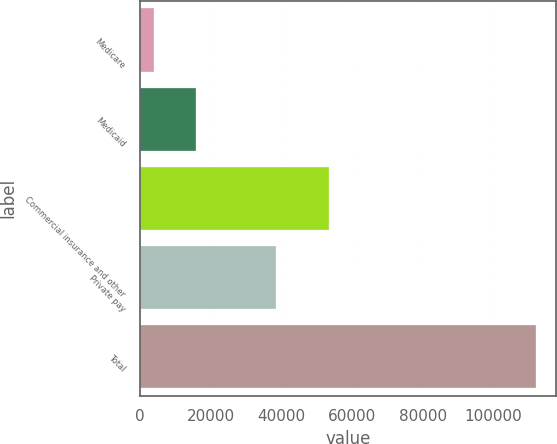Convert chart to OTSL. <chart><loc_0><loc_0><loc_500><loc_500><bar_chart><fcel>Medicare<fcel>Medicaid<fcel>Commercial insurance and other<fcel>Private pay<fcel>Total<nl><fcel>3993<fcel>16049<fcel>53539<fcel>38510<fcel>112091<nl></chart> 